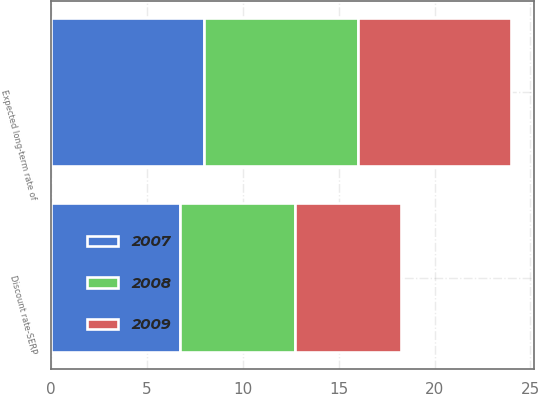Convert chart to OTSL. <chart><loc_0><loc_0><loc_500><loc_500><stacked_bar_chart><ecel><fcel>Discount rate-SERP<fcel>Expected long-term rate of<nl><fcel>2007<fcel>6.75<fcel>8<nl><fcel>2008<fcel>6<fcel>8<nl><fcel>2009<fcel>5.5<fcel>8<nl></chart> 